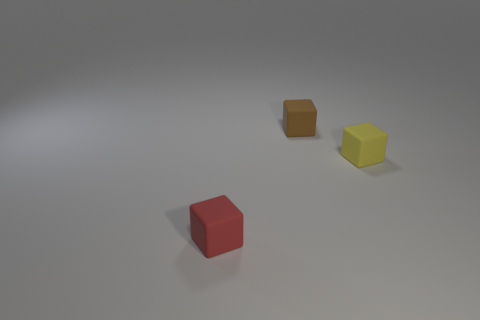How many rubber objects are behind the rubber block that is behind the yellow cube?
Keep it short and to the point. 0. How many cubes are small objects or tiny yellow things?
Give a very brief answer. 3. There is a small object that is in front of the brown rubber thing and left of the yellow object; what is its color?
Your answer should be very brief. Red. There is a small rubber thing in front of the matte thing that is on the right side of the small brown matte cube; what is its color?
Your answer should be very brief. Red. Is the block behind the tiny yellow block made of the same material as the block that is on the right side of the brown matte cube?
Your answer should be compact. Yes. What is the shape of the thing that is in front of the cube on the right side of the tiny object that is behind the small yellow matte thing?
Keep it short and to the point. Cube. Is the number of brown matte blocks greater than the number of gray objects?
Your answer should be compact. Yes. Is there a large red shiny block?
Give a very brief answer. No. What number of objects are either small matte objects on the right side of the brown rubber thing or blocks that are on the left side of the yellow rubber object?
Provide a succinct answer. 3. Are there fewer red rubber cubes than cubes?
Give a very brief answer. Yes. 